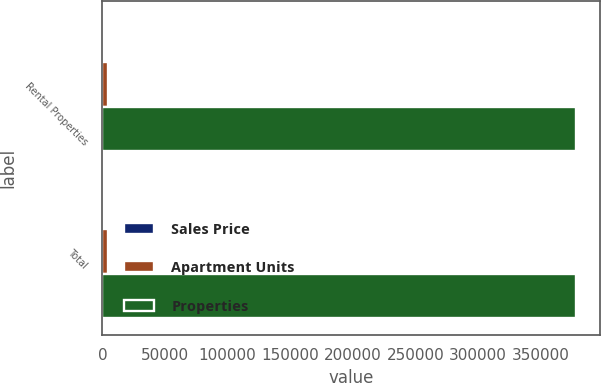<chart> <loc_0><loc_0><loc_500><loc_500><stacked_bar_chart><ecel><fcel>Rental Properties<fcel>Total<nl><fcel>Sales Price<fcel>15<fcel>15<nl><fcel>Apartment Units<fcel>4152<fcel>4152<nl><fcel>Properties<fcel>378650<fcel>378650<nl></chart> 